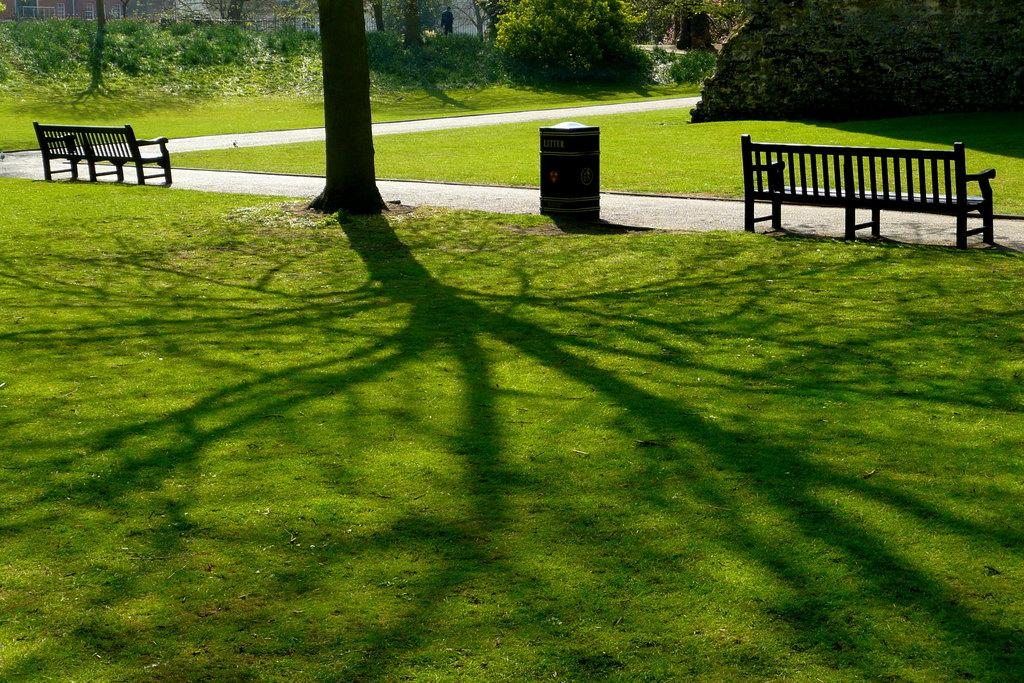What type of vegetation can be seen in the image? There is grass in the image. What type of seating is available in the image? There are benches in the image. What type of receptacle is present in the image? There is a bin in the image. What part of a tree is visible in the image? There is a tree trunk in the image. What can be seen in the background of the image? In the background, there are plants, trees, and a person visible. What type of cabbage is being used as an attraction in the image? There is no cabbage present in the image, nor is there any indication of an attraction. What type of cloth is draped over the tree trunk in the image? There is no cloth draped over the tree trunk in the image; only the tree trunk is visible. 